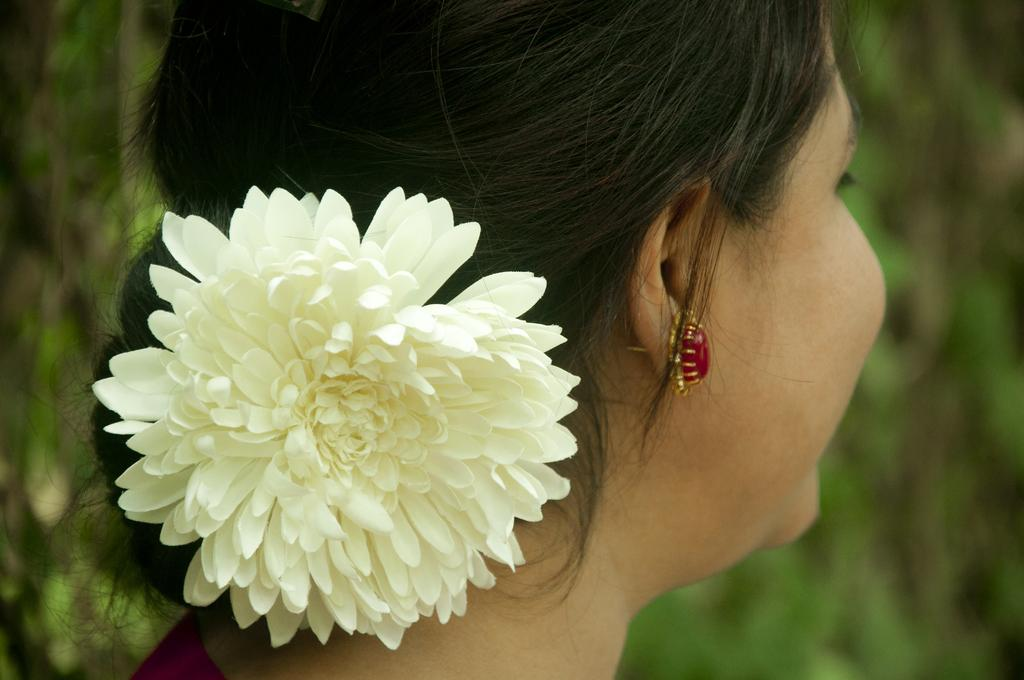Who is the main subject in the image? There is a lady in the image. What can be seen in the lady's hair? The lady has a flower in her hair. Can you describe the background of the image? The background of the image is blurred. What type of bread is being baked in the oven in the image? There is no oven or bread present in the image. Can you describe the ray of light in the image? There is no ray of light present in the image. 